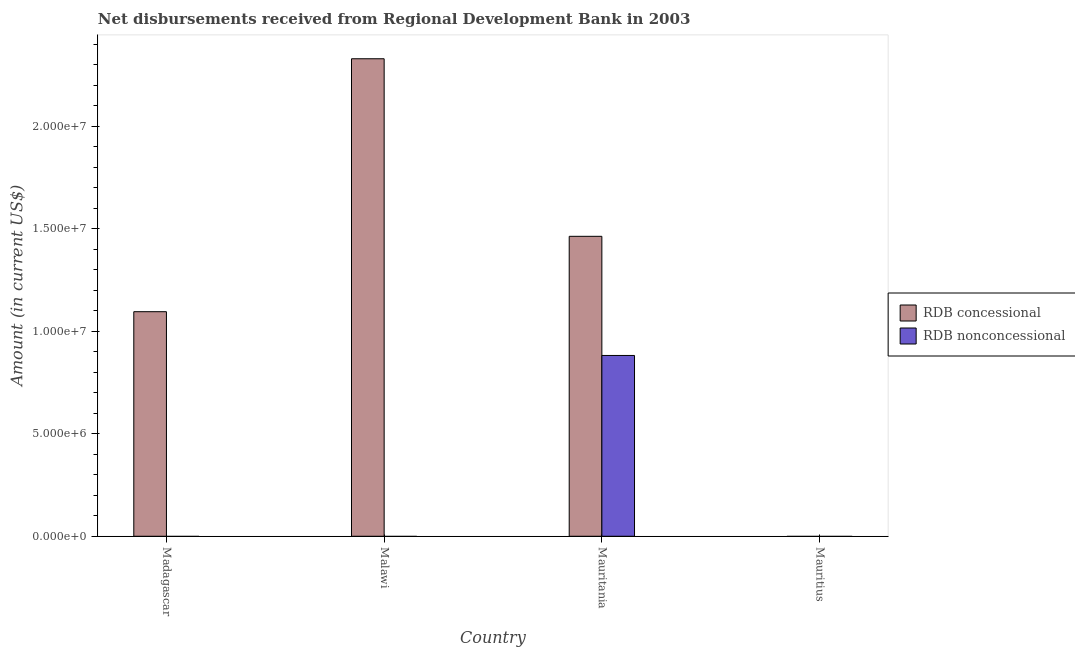How many different coloured bars are there?
Your answer should be very brief. 2. How many bars are there on the 1st tick from the left?
Provide a short and direct response. 1. How many bars are there on the 3rd tick from the right?
Your answer should be very brief. 1. What is the label of the 3rd group of bars from the left?
Make the answer very short. Mauritania. What is the net concessional disbursements from rdb in Madagascar?
Your answer should be very brief. 1.10e+07. Across all countries, what is the maximum net concessional disbursements from rdb?
Your answer should be compact. 2.33e+07. Across all countries, what is the minimum net concessional disbursements from rdb?
Your response must be concise. 0. In which country was the net non concessional disbursements from rdb maximum?
Keep it short and to the point. Mauritania. What is the total net non concessional disbursements from rdb in the graph?
Make the answer very short. 8.82e+06. What is the difference between the net concessional disbursements from rdb in Malawi and that in Mauritania?
Provide a succinct answer. 8.66e+06. What is the difference between the net non concessional disbursements from rdb in Malawi and the net concessional disbursements from rdb in Mauritius?
Your response must be concise. 0. What is the average net concessional disbursements from rdb per country?
Offer a terse response. 1.22e+07. What is the difference between the net non concessional disbursements from rdb and net concessional disbursements from rdb in Mauritania?
Your answer should be compact. -5.81e+06. What is the ratio of the net concessional disbursements from rdb in Malawi to that in Mauritania?
Your response must be concise. 1.59. Is the net concessional disbursements from rdb in Madagascar less than that in Mauritania?
Your answer should be compact. Yes. What is the difference between the highest and the second highest net concessional disbursements from rdb?
Provide a succinct answer. 8.66e+06. What is the difference between the highest and the lowest net non concessional disbursements from rdb?
Keep it short and to the point. 8.82e+06. In how many countries, is the net non concessional disbursements from rdb greater than the average net non concessional disbursements from rdb taken over all countries?
Your answer should be compact. 1. How many countries are there in the graph?
Offer a terse response. 4. What is the difference between two consecutive major ticks on the Y-axis?
Offer a very short reply. 5.00e+06. Does the graph contain any zero values?
Keep it short and to the point. Yes. Where does the legend appear in the graph?
Your response must be concise. Center right. How are the legend labels stacked?
Your answer should be very brief. Vertical. What is the title of the graph?
Give a very brief answer. Net disbursements received from Regional Development Bank in 2003. What is the label or title of the X-axis?
Offer a very short reply. Country. What is the Amount (in current US$) in RDB concessional in Madagascar?
Give a very brief answer. 1.10e+07. What is the Amount (in current US$) of RDB concessional in Malawi?
Your answer should be compact. 2.33e+07. What is the Amount (in current US$) of RDB nonconcessional in Malawi?
Give a very brief answer. 0. What is the Amount (in current US$) in RDB concessional in Mauritania?
Your response must be concise. 1.46e+07. What is the Amount (in current US$) of RDB nonconcessional in Mauritania?
Your answer should be compact. 8.82e+06. What is the Amount (in current US$) in RDB concessional in Mauritius?
Your response must be concise. 0. What is the Amount (in current US$) of RDB nonconcessional in Mauritius?
Give a very brief answer. 0. Across all countries, what is the maximum Amount (in current US$) of RDB concessional?
Give a very brief answer. 2.33e+07. Across all countries, what is the maximum Amount (in current US$) of RDB nonconcessional?
Your answer should be compact. 8.82e+06. Across all countries, what is the minimum Amount (in current US$) of RDB concessional?
Your answer should be compact. 0. What is the total Amount (in current US$) in RDB concessional in the graph?
Provide a succinct answer. 4.89e+07. What is the total Amount (in current US$) in RDB nonconcessional in the graph?
Your answer should be compact. 8.82e+06. What is the difference between the Amount (in current US$) of RDB concessional in Madagascar and that in Malawi?
Your response must be concise. -1.23e+07. What is the difference between the Amount (in current US$) in RDB concessional in Madagascar and that in Mauritania?
Provide a short and direct response. -3.68e+06. What is the difference between the Amount (in current US$) in RDB concessional in Malawi and that in Mauritania?
Your response must be concise. 8.66e+06. What is the difference between the Amount (in current US$) of RDB concessional in Madagascar and the Amount (in current US$) of RDB nonconcessional in Mauritania?
Provide a succinct answer. 2.14e+06. What is the difference between the Amount (in current US$) in RDB concessional in Malawi and the Amount (in current US$) in RDB nonconcessional in Mauritania?
Offer a very short reply. 1.45e+07. What is the average Amount (in current US$) of RDB concessional per country?
Ensure brevity in your answer.  1.22e+07. What is the average Amount (in current US$) in RDB nonconcessional per country?
Offer a terse response. 2.21e+06. What is the difference between the Amount (in current US$) in RDB concessional and Amount (in current US$) in RDB nonconcessional in Mauritania?
Your answer should be compact. 5.81e+06. What is the ratio of the Amount (in current US$) in RDB concessional in Madagascar to that in Malawi?
Keep it short and to the point. 0.47. What is the ratio of the Amount (in current US$) of RDB concessional in Madagascar to that in Mauritania?
Your response must be concise. 0.75. What is the ratio of the Amount (in current US$) in RDB concessional in Malawi to that in Mauritania?
Offer a terse response. 1.59. What is the difference between the highest and the second highest Amount (in current US$) of RDB concessional?
Provide a succinct answer. 8.66e+06. What is the difference between the highest and the lowest Amount (in current US$) in RDB concessional?
Ensure brevity in your answer.  2.33e+07. What is the difference between the highest and the lowest Amount (in current US$) of RDB nonconcessional?
Ensure brevity in your answer.  8.82e+06. 